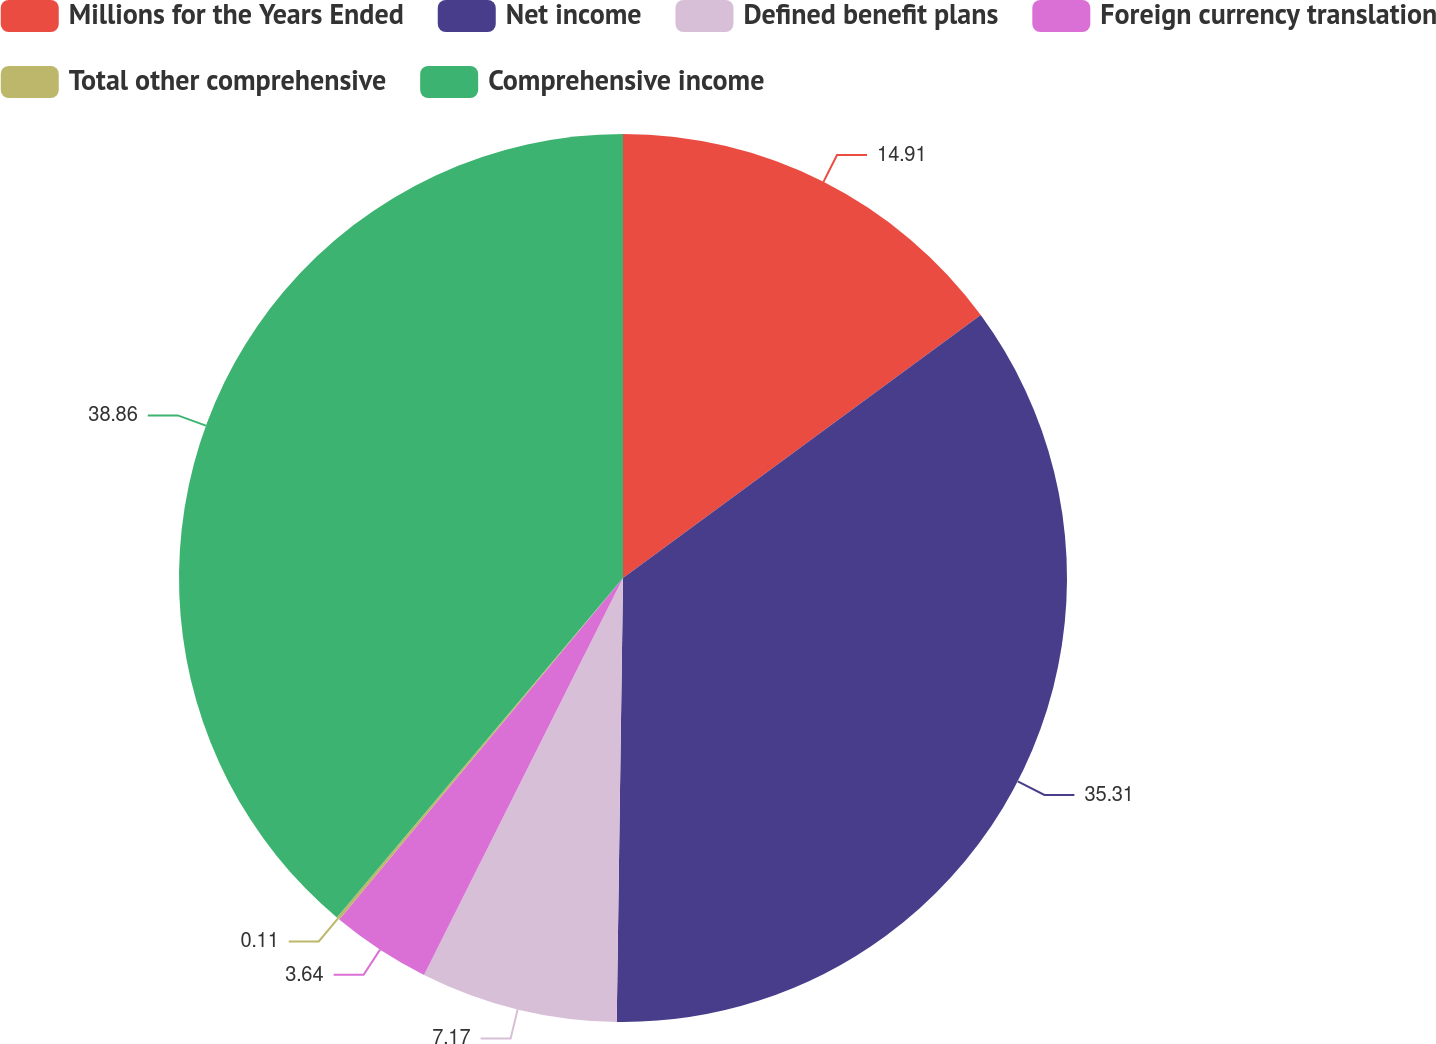<chart> <loc_0><loc_0><loc_500><loc_500><pie_chart><fcel>Millions for the Years Ended<fcel>Net income<fcel>Defined benefit plans<fcel>Foreign currency translation<fcel>Total other comprehensive<fcel>Comprehensive income<nl><fcel>14.91%<fcel>35.31%<fcel>7.17%<fcel>3.64%<fcel>0.11%<fcel>38.85%<nl></chart> 